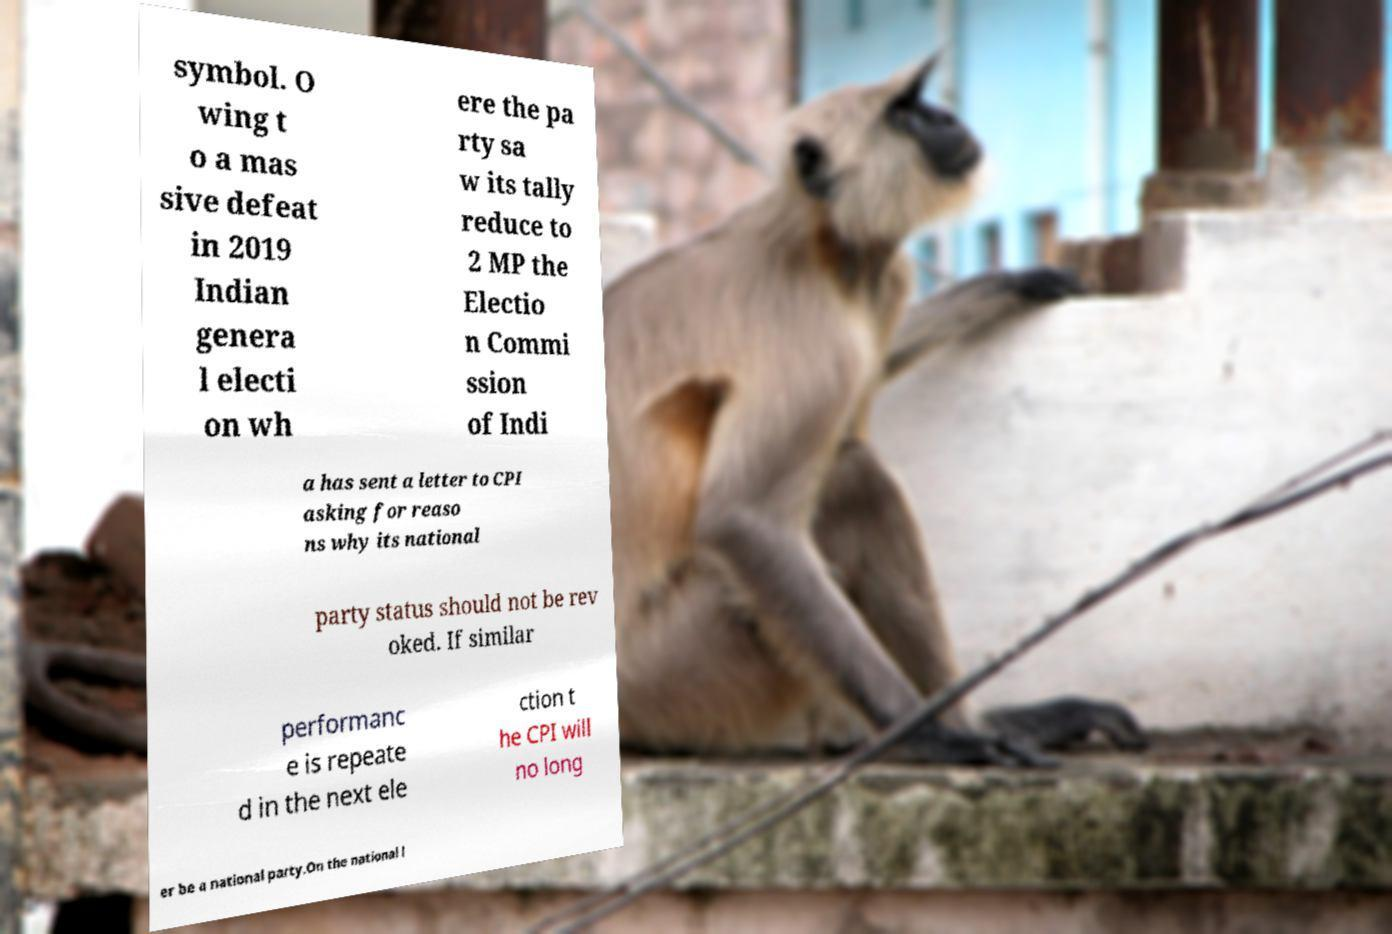Could you extract and type out the text from this image? symbol. O wing t o a mas sive defeat in 2019 Indian genera l electi on wh ere the pa rty sa w its tally reduce to 2 MP the Electio n Commi ssion of Indi a has sent a letter to CPI asking for reaso ns why its national party status should not be rev oked. If similar performanc e is repeate d in the next ele ction t he CPI will no long er be a national party.On the national l 